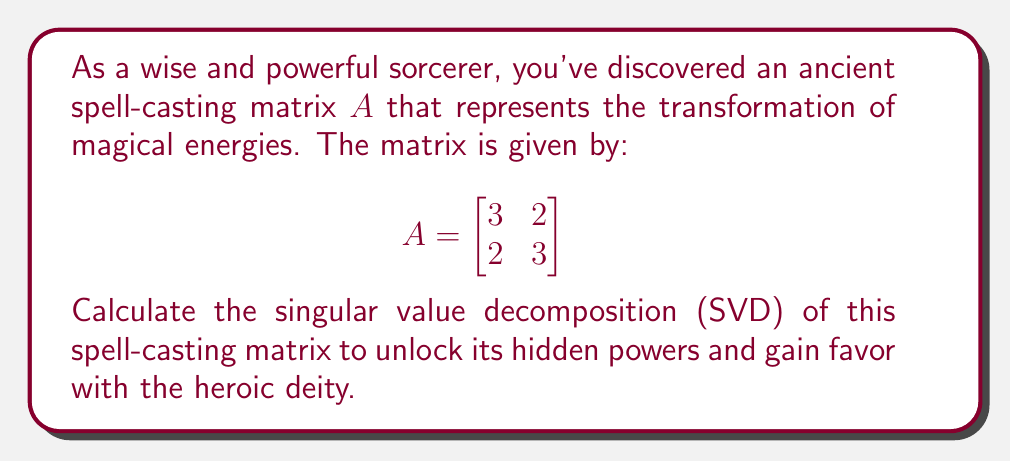Give your solution to this math problem. To find the singular value decomposition (SVD) of matrix $A$, we need to determine $U$, $\Sigma$, and $V^T$ such that $A = U\Sigma V^T$.

Step 1: Calculate $A^TA$ and $AA^T$
$$A^TA = \begin{bmatrix}
3 & 2 \\
2 & 3
\end{bmatrix} \begin{bmatrix}
3 & 2 \\
2 & 3
\end{bmatrix} = \begin{bmatrix}
13 & 12 \\
12 & 13
\end{bmatrix}$$

$$AA^T = \begin{bmatrix}
3 & 2 \\
2 & 3
\end{bmatrix} \begin{bmatrix}
3 & 2 \\
2 & 3
\end{bmatrix} = \begin{bmatrix}
13 & 12 \\
12 & 13
\end{bmatrix}$$

Step 2: Find eigenvalues of $A^TA$ (or $AA^T$)
$\det(A^TA - \lambda I) = \begin{vmatrix}
13-\lambda & 12 \\
12 & 13-\lambda
\end{vmatrix} = (13-\lambda)^2 - 144 = \lambda^2 - 26\lambda + 25 = 0$

Solving this quadratic equation:
$\lambda_1 = 25, \lambda_2 = 1$

Step 3: Calculate singular values
$\sigma_1 = \sqrt{25} = 5, \sigma_2 = \sqrt{1} = 1$

Step 4: Find eigenvectors of $A^TA$ to get $V$
For $\lambda_1 = 25$:
$(A^TA - 25I)\mathbf{v_1} = \mathbf{0}$
$\begin{bmatrix}
-12 & 12 \\
12 & -12
\end{bmatrix}\mathbf{v_1} = \mathbf{0}$
$\mathbf{v_1} = \frac{1}{\sqrt{2}}[1, 1]^T$

For $\lambda_2 = 1$:
$(A^TA - I)\mathbf{v_2} = \mathbf{0}$
$\begin{bmatrix}
12 & 12 \\
12 & 12
\end{bmatrix}\mathbf{v_2} = \mathbf{0}$
$\mathbf{v_2} = \frac{1}{\sqrt{2}}[-1, 1]^T$

$V = \begin{bmatrix}
\frac{1}{\sqrt{2}} & -\frac{1}{\sqrt{2}} \\
\frac{1}{\sqrt{2}} & \frac{1}{\sqrt{2}}
\end{bmatrix}$

Step 5: Calculate $U$ using $U = AV\Sigma^{-1}$
$U = \frac{1}{5\sqrt{2}}\begin{bmatrix}
3 & 2 \\
2 & 3
\end{bmatrix}\begin{bmatrix}
1 & -1 \\
1 & 1
\end{bmatrix}\begin{bmatrix}
1 & 0 \\
0 & 5
\end{bmatrix} = \begin{bmatrix}
\frac{1}{\sqrt{2}} & -\frac{1}{\sqrt{2}} \\
\frac{1}{\sqrt{2}} & \frac{1}{\sqrt{2}}
\end{bmatrix}$

Therefore, the singular value decomposition of $A$ is:

$A = U\Sigma V^T = \begin{bmatrix}
\frac{1}{\sqrt{2}} & -\frac{1}{\sqrt{2}} \\
\frac{1}{\sqrt{2}} & \frac{1}{\sqrt{2}}
\end{bmatrix}\begin{bmatrix}
5 & 0 \\
0 & 1
\end{bmatrix}\begin{bmatrix}
\frac{1}{\sqrt{2}} & \frac{1}{\sqrt{2}} \\
-\frac{1}{\sqrt{2}} & \frac{1}{\sqrt{2}}
\end{bmatrix}$
Answer: $A = \begin{bmatrix}
\frac{1}{\sqrt{2}} & -\frac{1}{\sqrt{2}} \\
\frac{1}{\sqrt{2}} & \frac{1}{\sqrt{2}}
\end{bmatrix}\begin{bmatrix}
5 & 0 \\
0 & 1
\end{bmatrix}\begin{bmatrix}
\frac{1}{\sqrt{2}} & \frac{1}{\sqrt{2}} \\
-\frac{1}{\sqrt{2}} & \frac{1}{\sqrt{2}}
\end{bmatrix}$ 